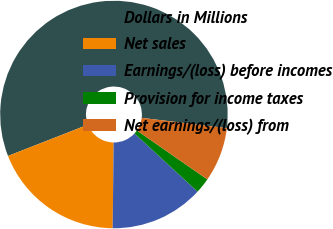Convert chart. <chart><loc_0><loc_0><loc_500><loc_500><pie_chart><fcel>Dollars in Millions<fcel>Net sales<fcel>Earnings/(loss) before incomes<fcel>Provision for income taxes<fcel>Net earnings/(loss) from<nl><fcel>57.85%<fcel>18.89%<fcel>13.32%<fcel>2.19%<fcel>7.76%<nl></chart> 